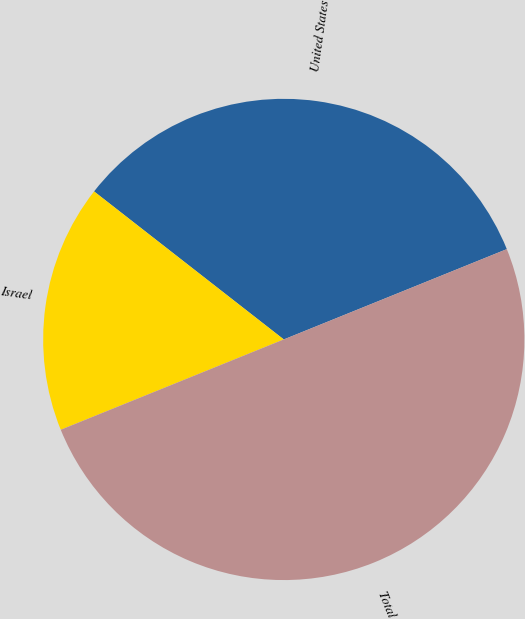Convert chart to OTSL. <chart><loc_0><loc_0><loc_500><loc_500><pie_chart><fcel>United States<fcel>Israel<fcel>Total<nl><fcel>33.33%<fcel>16.67%<fcel>50.0%<nl></chart> 